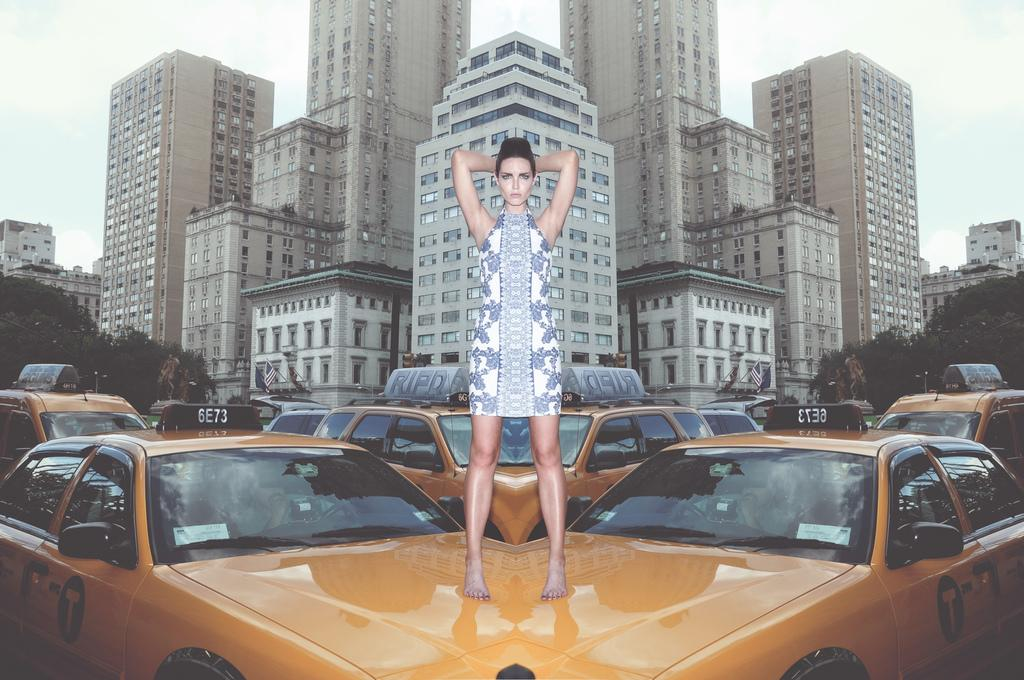<image>
Summarize the visual content of the image. A barefoot woman stands on two taxi cabs that each have a large T on the door. 